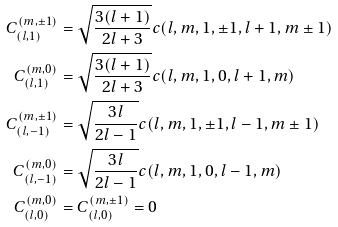Convert formula to latex. <formula><loc_0><loc_0><loc_500><loc_500>C _ { ( l , 1 ) } ^ { ( m , \pm 1 ) } & = \sqrt { \frac { 3 ( l + 1 ) } { 2 l + 3 } } c ( l , m , 1 , \pm 1 , l + 1 , m \pm 1 ) \\ C _ { ( l , 1 ) } ^ { ( m , 0 ) } & = \sqrt { \frac { 3 ( l + 1 ) } { 2 l + 3 } } c ( l , m , 1 , 0 , l + 1 , m ) \\ C _ { ( l , - 1 ) } ^ { ( m , \pm 1 ) } & = \sqrt { \frac { 3 l } { 2 l - 1 } } c ( l , m , 1 , \pm 1 , l - 1 , m \pm 1 ) \\ C _ { ( l , - 1 ) } ^ { ( m , 0 ) } & = \sqrt { \frac { 3 l } { 2 l - 1 } } c ( l , m , 1 , 0 , l - 1 , m ) \\ C _ { ( l , 0 ) } ^ { ( m , 0 ) } & = C _ { ( l , 0 ) } ^ { ( m , \pm 1 ) } = 0</formula> 